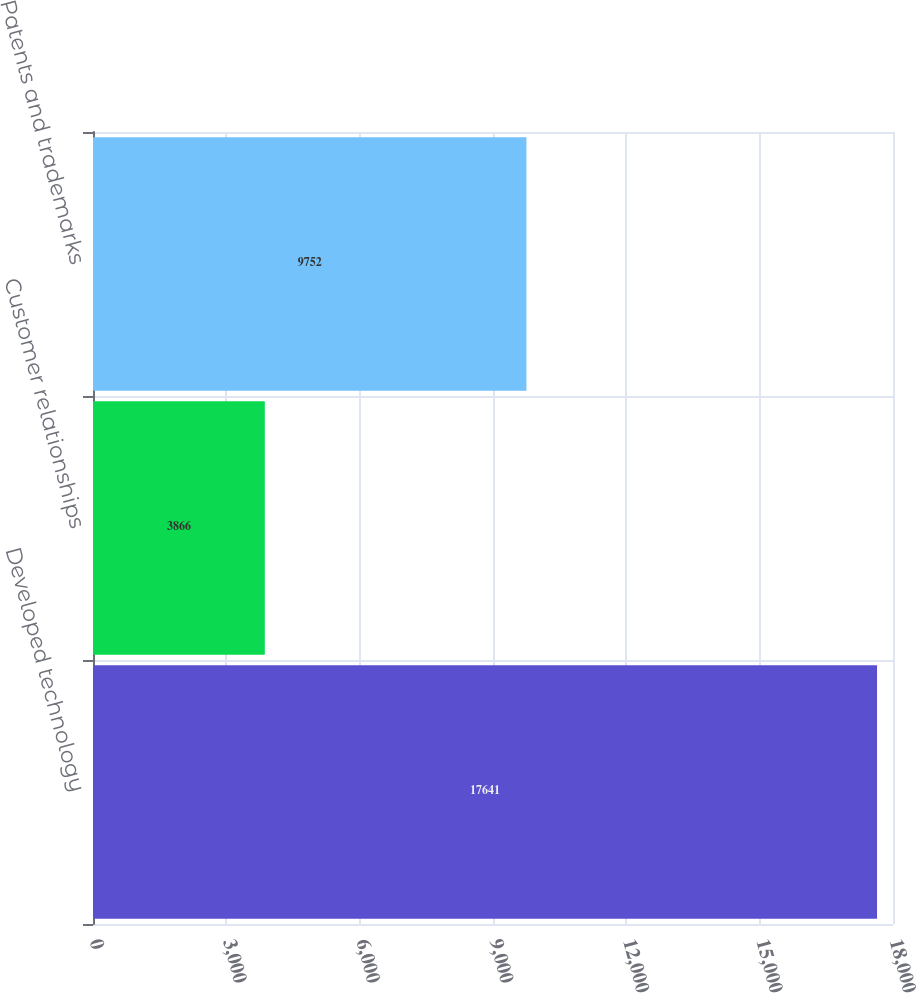<chart> <loc_0><loc_0><loc_500><loc_500><bar_chart><fcel>Developed technology<fcel>Customer relationships<fcel>Patents and trademarks<nl><fcel>17641<fcel>3866<fcel>9752<nl></chart> 